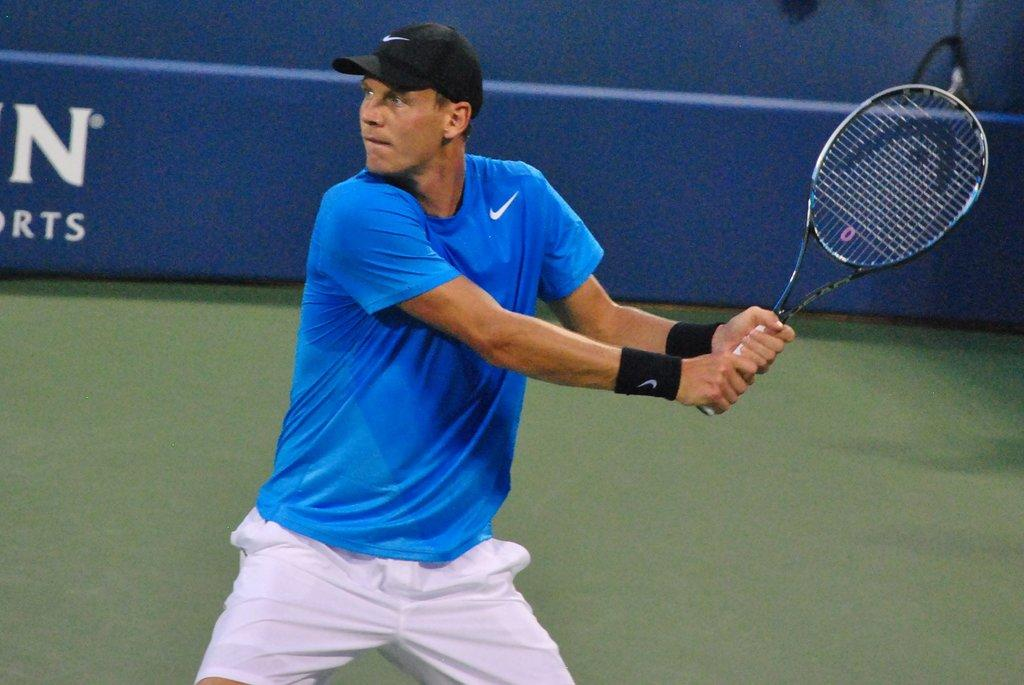What is the main subject of the image? The main subject of the image is a man. What is the man holding in the image? The man is holding a bat. What type of headwear is the man wearing in the image? The man is wearing a cap. Can you see a giraffe in the image? No, there is no giraffe present in the image. What type of thrill does the man experience while holding the bat in the image? The image does not provide information about the man's emotions or experiences, so it cannot be determined from the picture. 